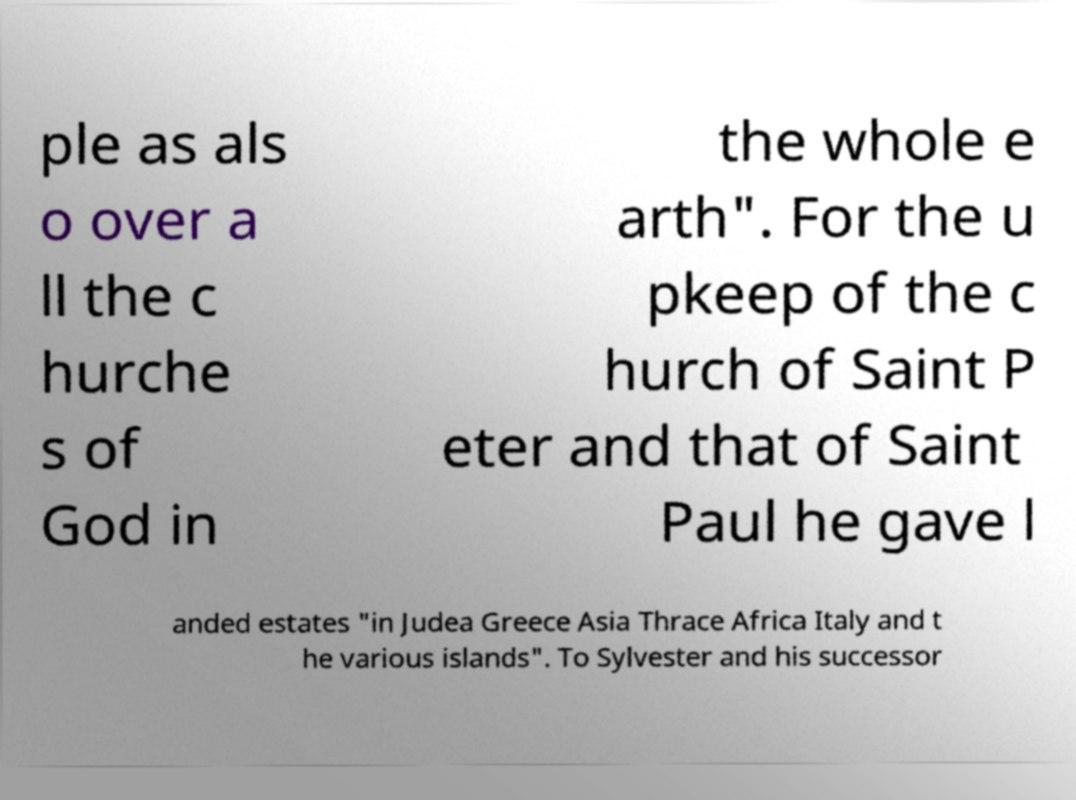I need the written content from this picture converted into text. Can you do that? ple as als o over a ll the c hurche s of God in the whole e arth". For the u pkeep of the c hurch of Saint P eter and that of Saint Paul he gave l anded estates "in Judea Greece Asia Thrace Africa Italy and t he various islands". To Sylvester and his successor 